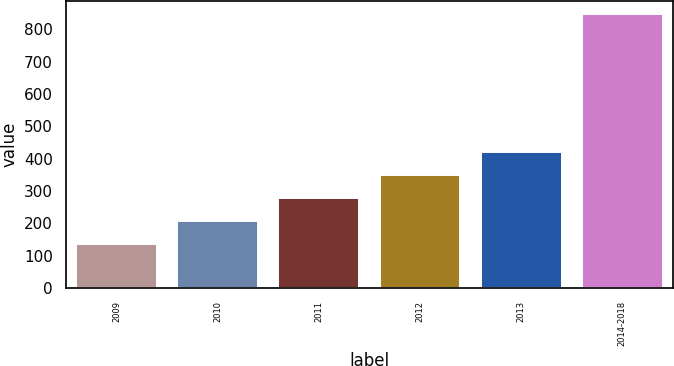Convert chart. <chart><loc_0><loc_0><loc_500><loc_500><bar_chart><fcel>2009<fcel>2010<fcel>2011<fcel>2012<fcel>2013<fcel>2014-2018<nl><fcel>135<fcel>206.2<fcel>277.4<fcel>348.6<fcel>419.8<fcel>847<nl></chart> 